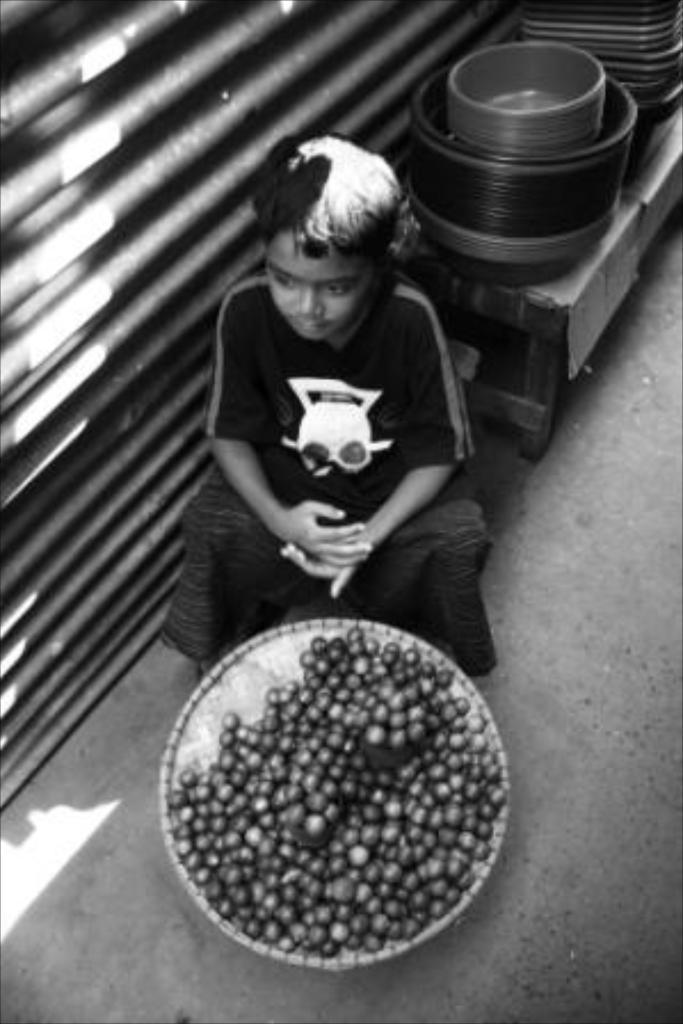Please provide a concise description of this image. In this picture we can see a kid is sitting, there is a basket in front of the kid, we can see some fruits in the basket, in the background there are some bowls, on the left side we can see a shutter, it is a black and white image. 